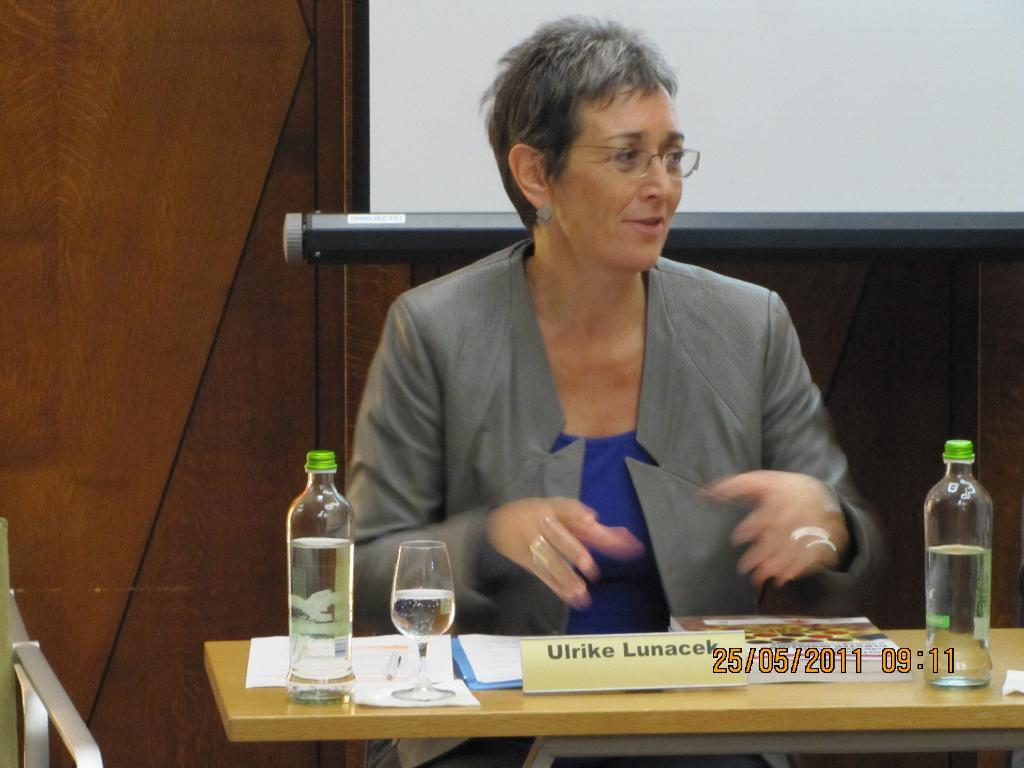<image>
Present a compact description of the photo's key features. Ulrike Lunacek using her hands to talk from a table. 